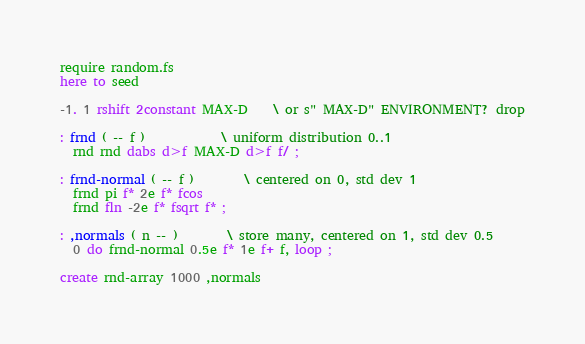<code> <loc_0><loc_0><loc_500><loc_500><_Forth_>require random.fs
here to seed

-1. 1 rshift 2constant MAX-D	\ or s" MAX-D" ENVIRONMENT? drop

: frnd ( -- f )			\ uniform distribution 0..1
  rnd rnd dabs d>f MAX-D d>f f/ ;

: frnd-normal ( -- f )		\ centered on 0, std dev 1
  frnd pi f* 2e f* fcos
  frnd fln -2e f* fsqrt f* ;

: ,normals ( n -- )		\ store many, centered on 1, std dev 0.5
  0 do frnd-normal 0.5e f* 1e f+ f, loop ;

create rnd-array 1000 ,normals
</code> 